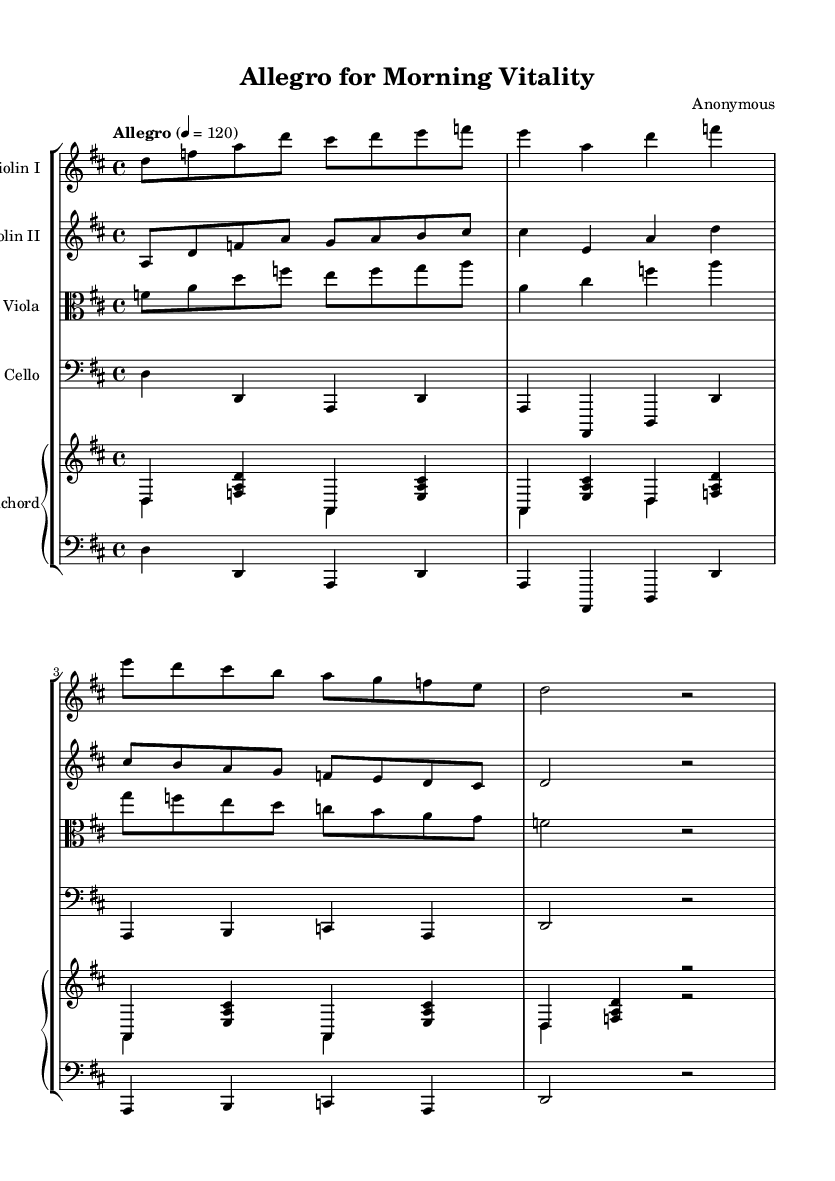What is the key signature of this music? The music is in D major, which has two sharps (F# and C#). This can be determined by looking at the key signature at the beginning of the staff.
Answer: D major What is the time signature of this piece? The time signature is 4/4, indicated at the beginning of the sheet music. This means there are four beats in a measure and the quarter note gets one beat.
Answer: 4/4 What is the tempo marking of this composition? The tempo marking is "Allegro," which indicates a fast and lively pace, often understood to be around 120 beats per minute as indicated within the tempo marking.
Answer: Allegro Which instrument features the highest range? The Violin I part features the highest range, as it is written in a higher octave compared to the other instruments, especially within the context of string ensembles.
Answer: Violin I How many measures are present in the score? The score contains 8 measures, which can be counted by looking at the bar lines separating the measures throughout the different instrumental parts.
Answer: 8 What is the instrumentation of this piece? The instrumentation includes two violins, a viola, a cello, and a harpsichord, as indicated by the labels above each staff in the score.
Answer: Two violins, viola, cello, harpsichord 